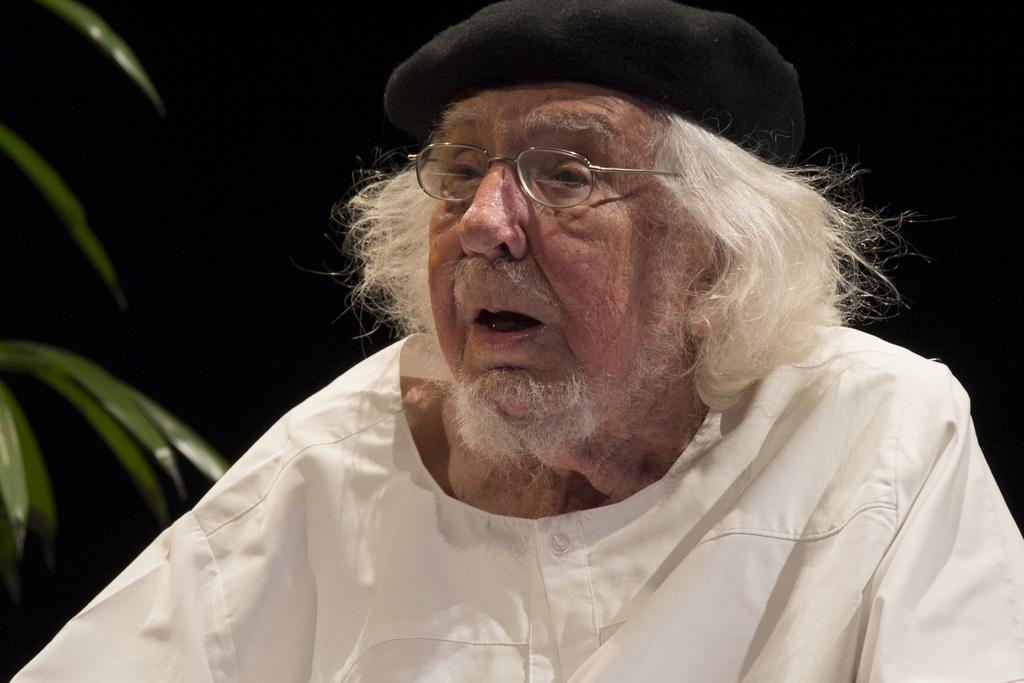What is the person in the image doing? The person is sitting in the image. Can you describe the person's attire? The person is wearing a cap. What can be seen on the left side of the image? There are leaves truncated towards the left of the image. How would you describe the overall lighting in the image? The background of the image is dark. What type of trail does the rat leave behind in the image? There is no rat present in the image, so no trail can be observed. What is the person holding in the image? The provided facts do not mention any object being held by the person, so it cannot be determined from the image. 